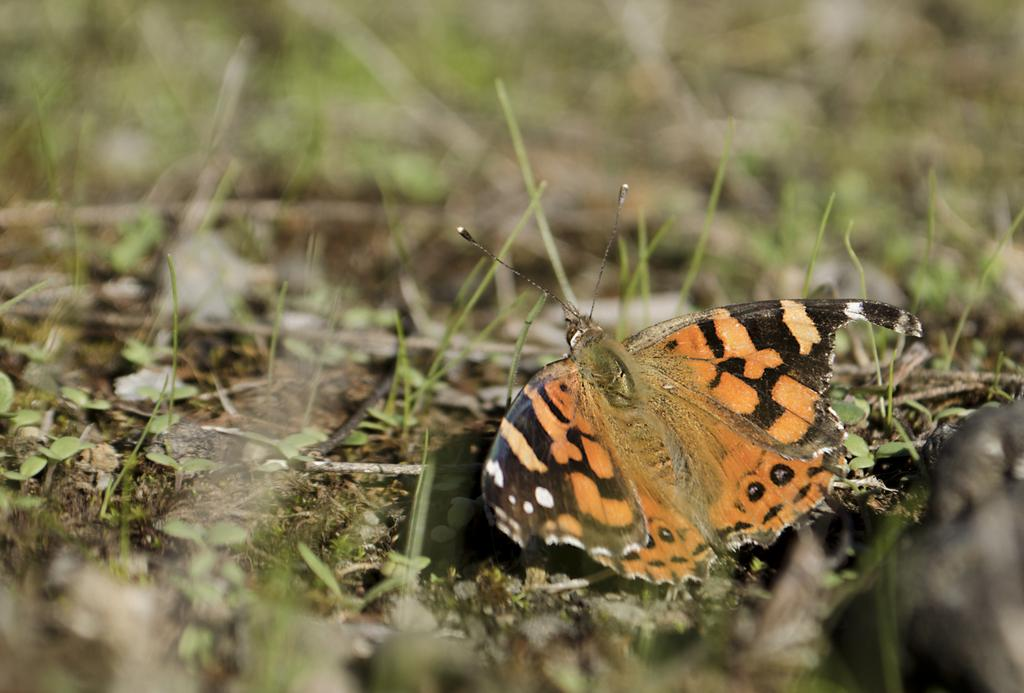What is the main subject of the picture? The main subject of the picture is a butterfly. Can you describe the colors of the butterfly? The butterfly has black and orange colors. Where is the butterfly located in the image? The butterfly is sitting on the ground. How would you describe the background of the image? The background is blurred in the image. What type of vegetation can be seen in the background? There is grass on the ground in the background. Can you tell me how much the vacation costs based on the receipt in the image? There is no receipt or mention of a vacation in the image; it features a butterfly sitting on the ground. What type of tank is visible in the image? There is no tank present in the image; it features a butterfly sitting on the ground. 